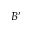<formula> <loc_0><loc_0><loc_500><loc_500>B ^ { \prime }</formula> 